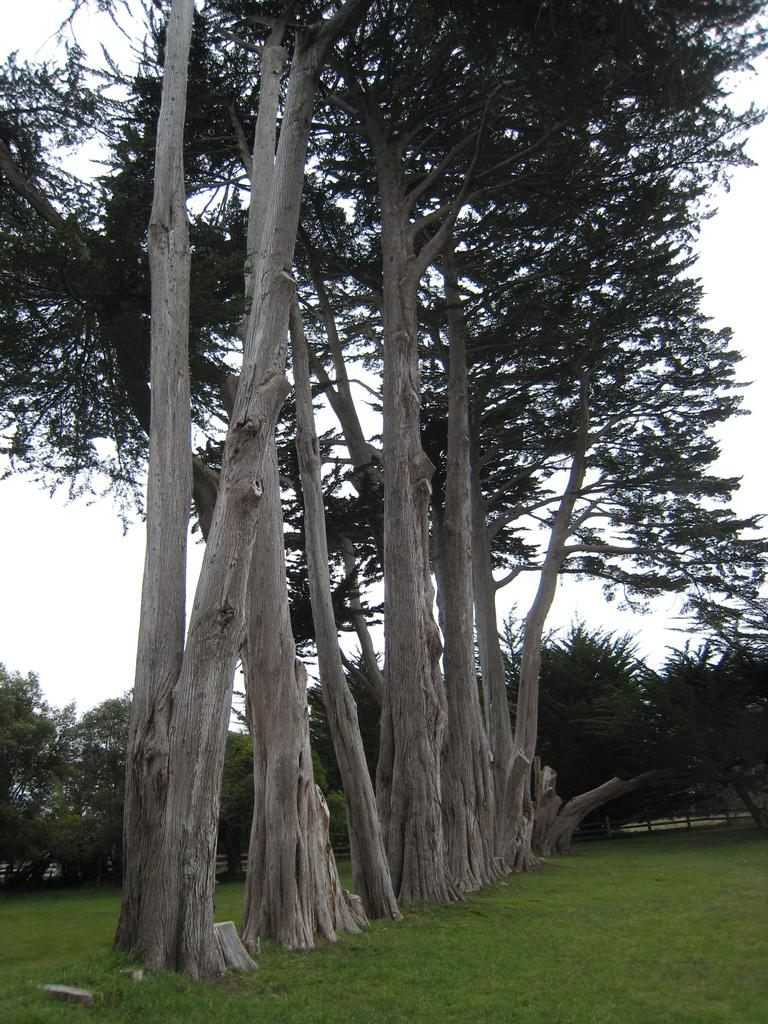What type of vegetation can be seen in the image? There are trees in the image. What is covering the ground in the image? There is grass on the floor in the image. Can you describe the background of the image? There are other trees in the background of the image. What is the condition of the sky in the image? The sky is clear in the image. What type of cream can be seen dripping from the trees in the image? There is no cream present in the image; it features trees and grass. Can you describe the trail that leads through the trees in the image? There is no trail present in the image; it only shows trees and grass. 